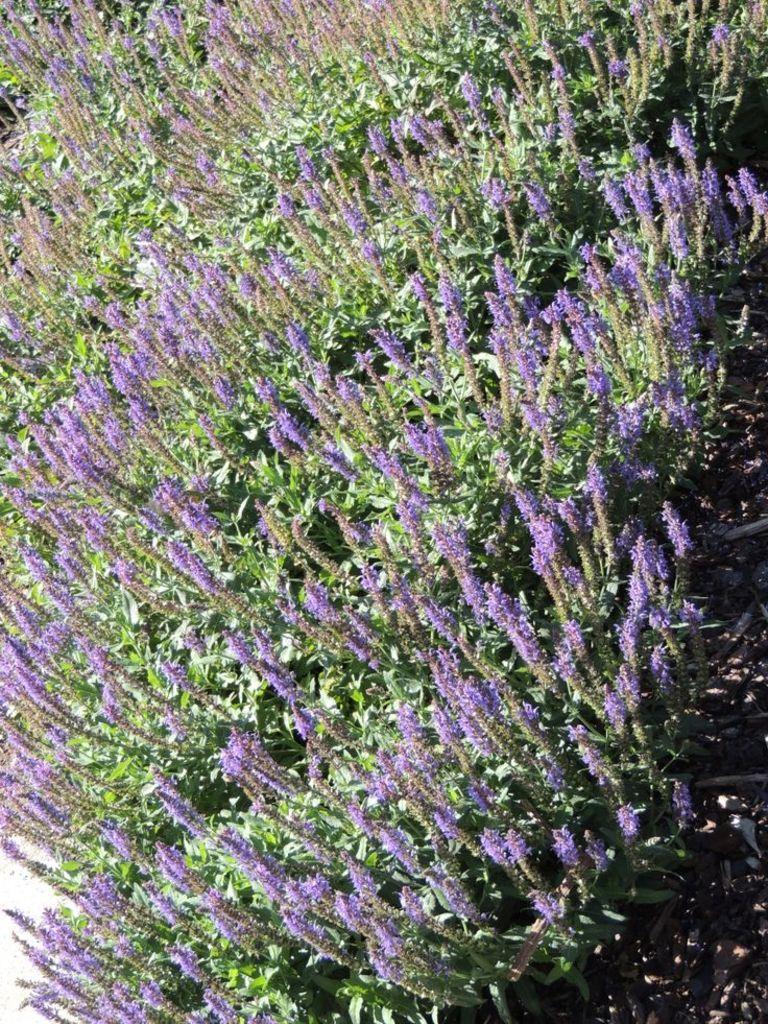Could you give a brief overview of what you see in this image? In this picture there is flower fields in the image. 